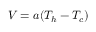<formula> <loc_0><loc_0><loc_500><loc_500>V = a ( T _ { h } - T _ { c } ) \,</formula> 